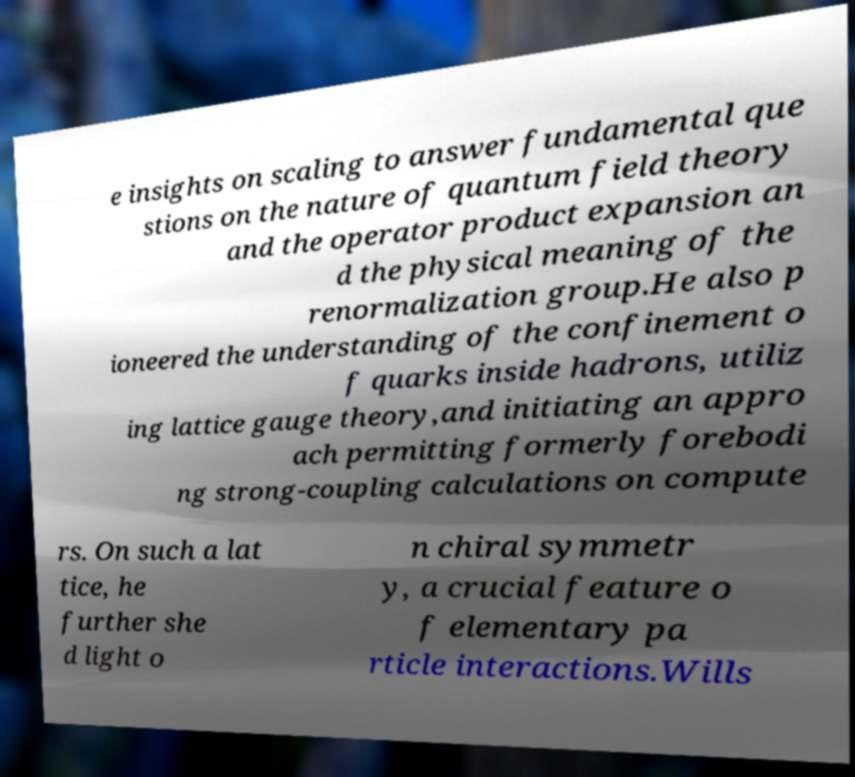What messages or text are displayed in this image? I need them in a readable, typed format. e insights on scaling to answer fundamental que stions on the nature of quantum field theory and the operator product expansion an d the physical meaning of the renormalization group.He also p ioneered the understanding of the confinement o f quarks inside hadrons, utiliz ing lattice gauge theory,and initiating an appro ach permitting formerly forebodi ng strong-coupling calculations on compute rs. On such a lat tice, he further she d light o n chiral symmetr y, a crucial feature o f elementary pa rticle interactions.Wills 